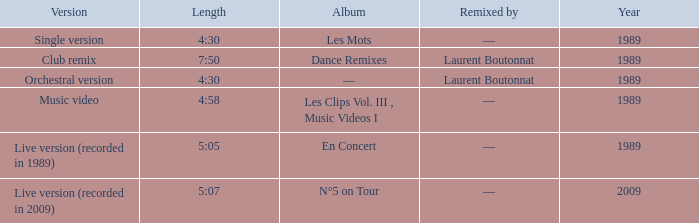In which year was the lowest point for the album "les mots"? 1989.0. 